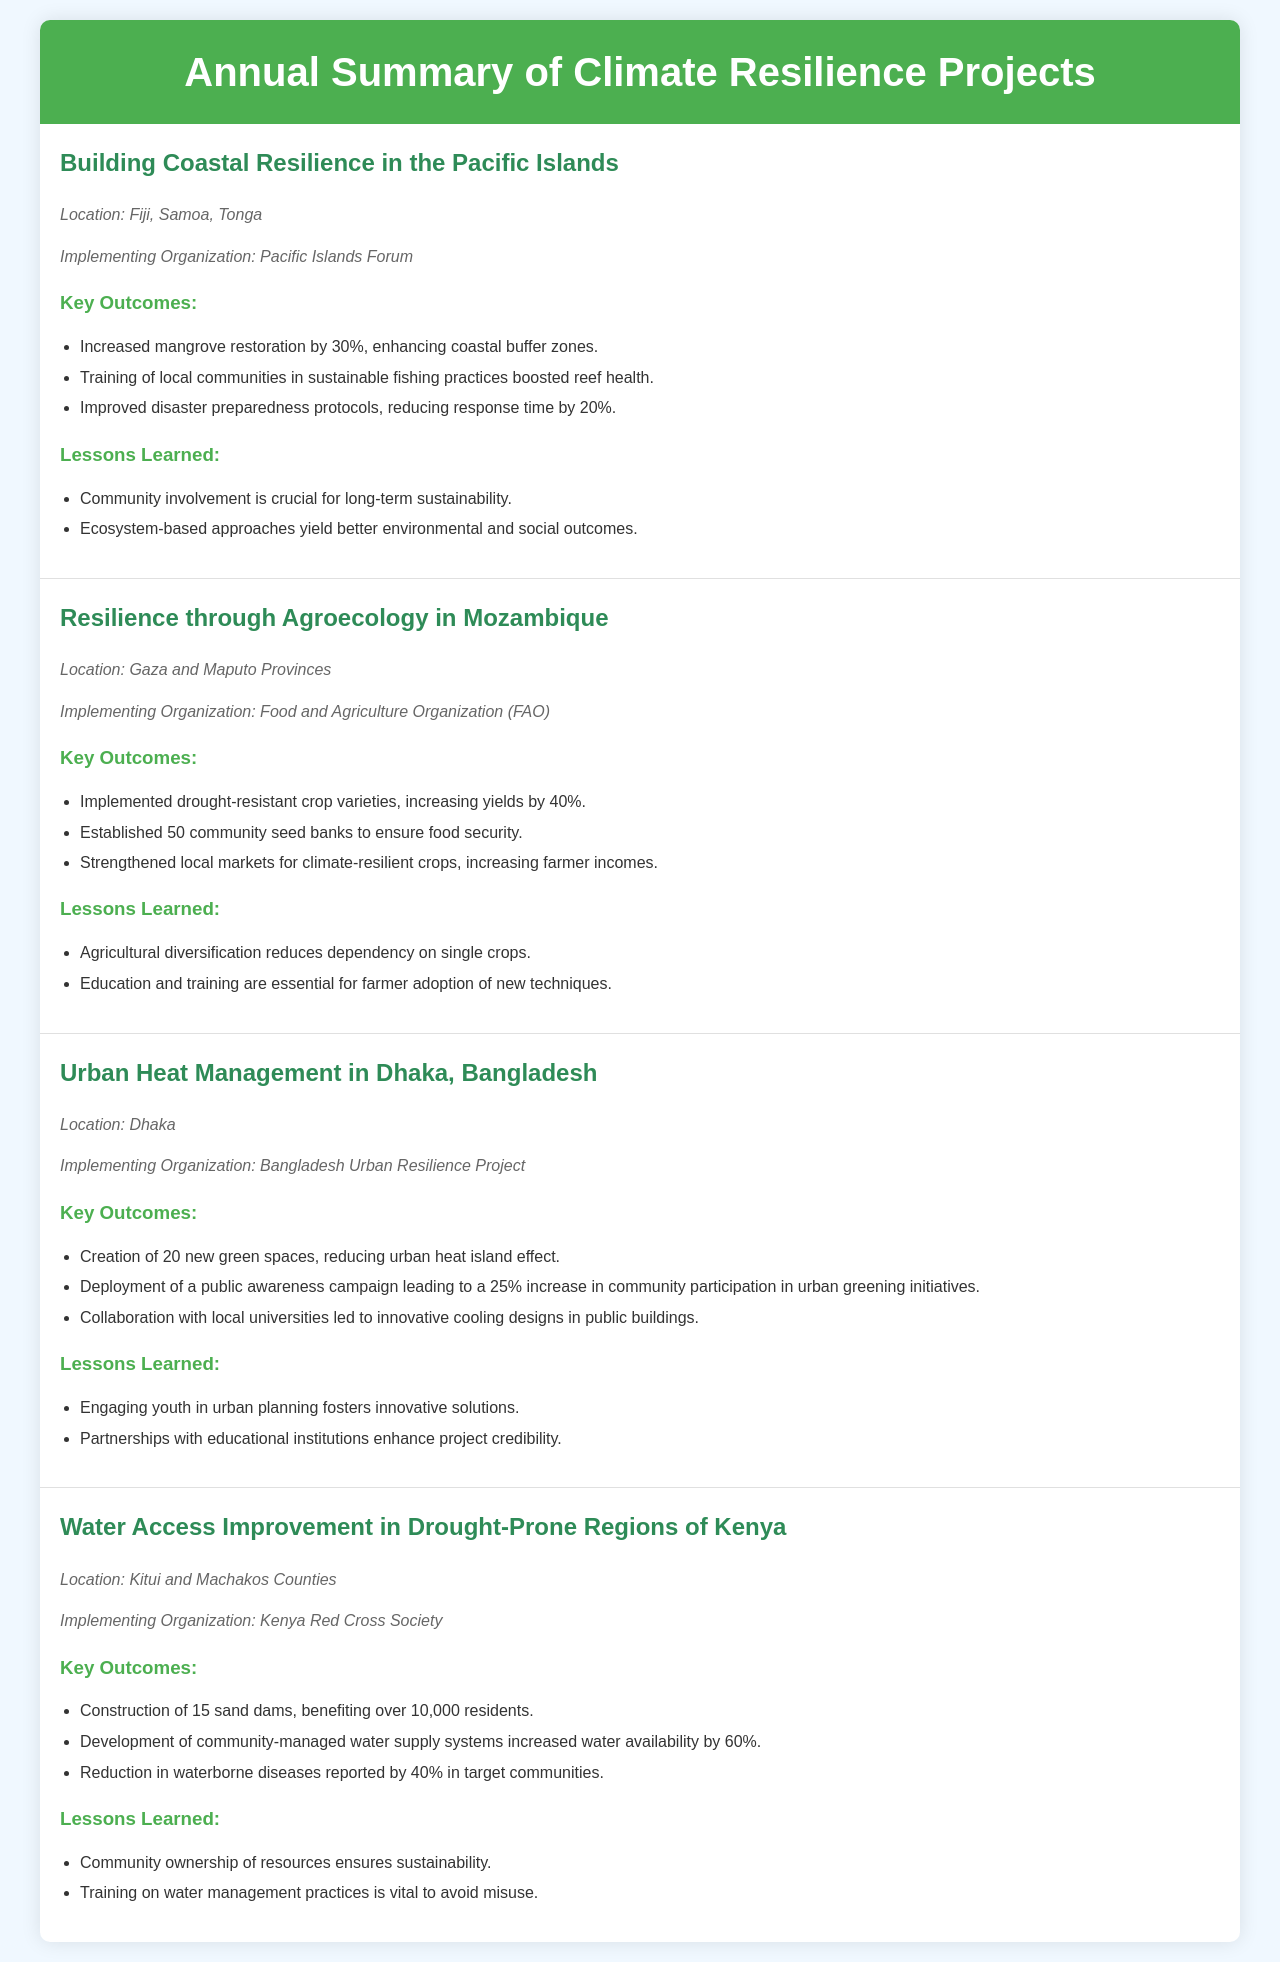what is the location of the building coastal resilience project? The location is specified as Fiji, Samoa, Tonga in the document.
Answer: Fiji, Samoa, Tonga who implemented the resilience through agroecology project? The implementing organization for this project is listed as the Food and Agriculture Organization (FAO).
Answer: Food and Agriculture Organization (FAO) how many new green spaces were created in Dhaka? The document states that 20 new green spaces were created as part of the project.
Answer: 20 what was the increase in yields for drought-resistant crops in Mozambique? The document indicates that yields increased by 40% due to the implementation of drought-resistant crop varieties.
Answer: 40% what key lesson was learned from the water access improvement project? One of the lessons learned emphasized that community ownership of resources ensures sustainability.
Answer: Community ownership of resources ensures sustainability which organization collaborated with local universities in Dhaka? The document states that the Bangladesh Urban Resilience Project collaborated with local universities.
Answer: Bangladesh Urban Resilience Project how much did water availability increase in drought-prone regions of Kenya? The increase in water availability is reported as 60% in the document.
Answer: 60% what kind of training boosted reef health in the Pacific Islands project? The document identifies training local communities in sustainable fishing practices as a key activity that boosted reef health.
Answer: sustainable fishing practices what was the reduction in waterborne diseases in Kenya? The reduction in waterborne diseases reported in the document is 40%.
Answer: 40% 